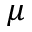<formula> <loc_0><loc_0><loc_500><loc_500>\mu</formula> 